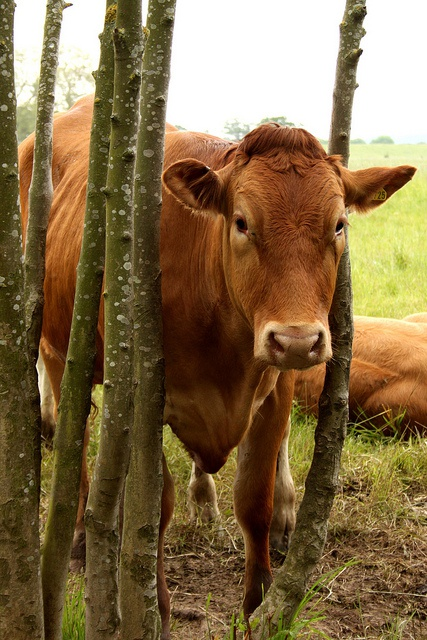Describe the objects in this image and their specific colors. I can see cow in darkgreen, maroon, black, brown, and tan tones and cow in darkgreen, brown, orange, maroon, and black tones in this image. 